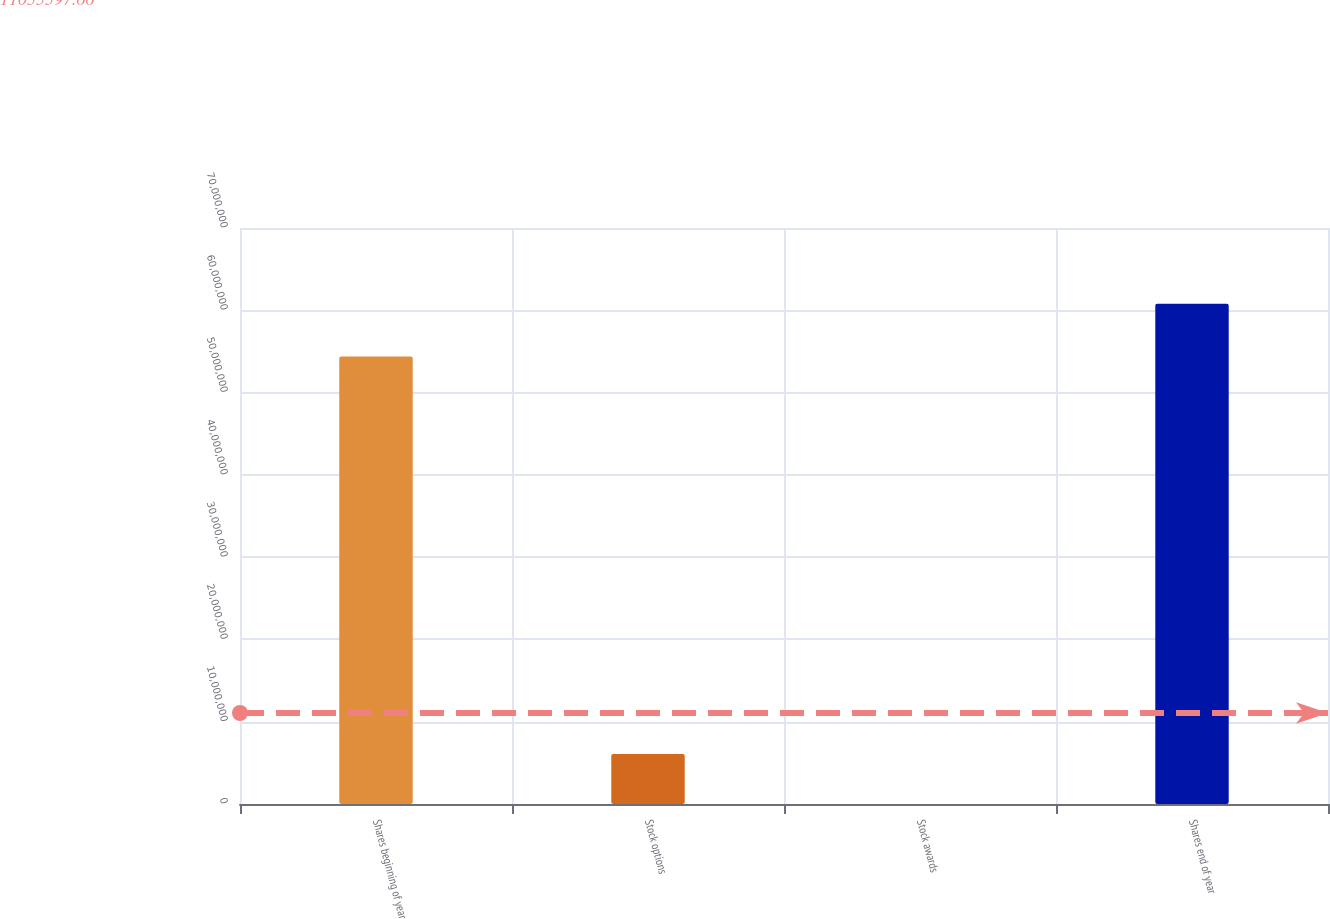<chart> <loc_0><loc_0><loc_500><loc_500><bar_chart><fcel>Shares beginning of year<fcel>Stock options<fcel>Stock awards<fcel>Shares end of year<nl><fcel>5.43727e+07<fcel>6.09113e+06<fcel>14291<fcel>6.07827e+07<nl></chart> 